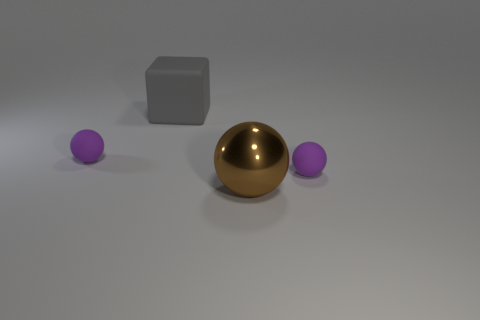What colors can be seen in the objects within this image? The image features objects in three distinct colors: there’s a grey block, a brown ball that has a metallic sheen, and two smaller purple balls. 